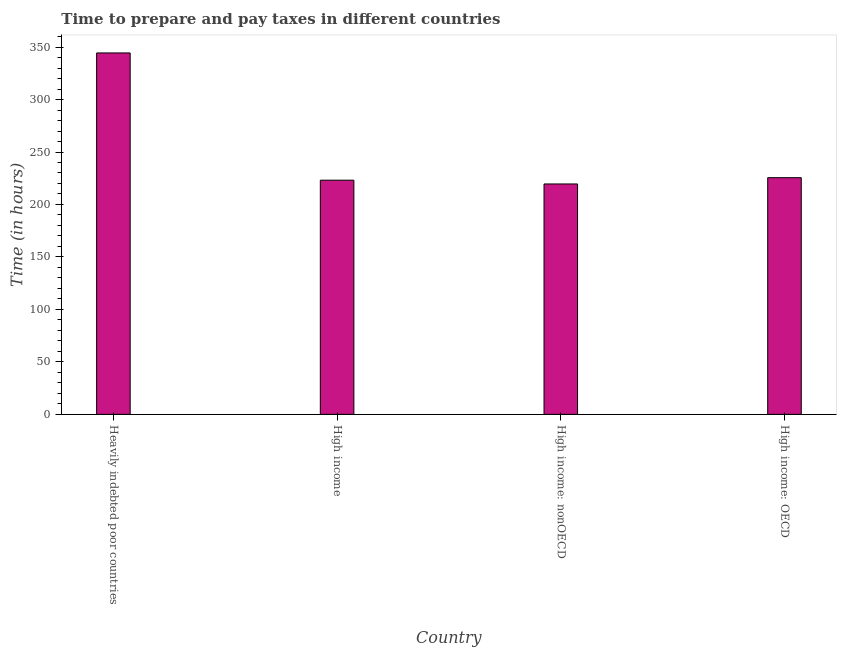Does the graph contain any zero values?
Offer a terse response. No. Does the graph contain grids?
Make the answer very short. No. What is the title of the graph?
Your response must be concise. Time to prepare and pay taxes in different countries. What is the label or title of the X-axis?
Your response must be concise. Country. What is the label or title of the Y-axis?
Provide a short and direct response. Time (in hours). What is the time to prepare and pay taxes in High income: nonOECD?
Provide a succinct answer. 219.55. Across all countries, what is the maximum time to prepare and pay taxes?
Make the answer very short. 344.39. Across all countries, what is the minimum time to prepare and pay taxes?
Provide a short and direct response. 219.55. In which country was the time to prepare and pay taxes maximum?
Your answer should be compact. Heavily indebted poor countries. In which country was the time to prepare and pay taxes minimum?
Your answer should be very brief. High income: nonOECD. What is the sum of the time to prepare and pay taxes?
Your answer should be very brief. 1012.62. What is the difference between the time to prepare and pay taxes in Heavily indebted poor countries and High income: nonOECD?
Keep it short and to the point. 124.84. What is the average time to prepare and pay taxes per country?
Your answer should be compact. 253.16. What is the median time to prepare and pay taxes?
Ensure brevity in your answer.  224.34. What is the ratio of the time to prepare and pay taxes in High income to that in High income: OECD?
Make the answer very short. 0.99. Is the time to prepare and pay taxes in High income less than that in High income: nonOECD?
Ensure brevity in your answer.  No. Is the difference between the time to prepare and pay taxes in High income and High income: OECD greater than the difference between any two countries?
Provide a succinct answer. No. What is the difference between the highest and the second highest time to prepare and pay taxes?
Your answer should be very brief. 118.86. What is the difference between the highest and the lowest time to prepare and pay taxes?
Your response must be concise. 124.84. In how many countries, is the time to prepare and pay taxes greater than the average time to prepare and pay taxes taken over all countries?
Provide a short and direct response. 1. What is the difference between two consecutive major ticks on the Y-axis?
Provide a succinct answer. 50. Are the values on the major ticks of Y-axis written in scientific E-notation?
Keep it short and to the point. No. What is the Time (in hours) in Heavily indebted poor countries?
Your answer should be very brief. 344.39. What is the Time (in hours) of High income?
Offer a terse response. 223.14. What is the Time (in hours) in High income: nonOECD?
Your answer should be compact. 219.55. What is the Time (in hours) of High income: OECD?
Your response must be concise. 225.53. What is the difference between the Time (in hours) in Heavily indebted poor countries and High income?
Provide a short and direct response. 121.25. What is the difference between the Time (in hours) in Heavily indebted poor countries and High income: nonOECD?
Offer a terse response. 124.84. What is the difference between the Time (in hours) in Heavily indebted poor countries and High income: OECD?
Your response must be concise. 118.86. What is the difference between the Time (in hours) in High income and High income: nonOECD?
Ensure brevity in your answer.  3.59. What is the difference between the Time (in hours) in High income and High income: OECD?
Your response must be concise. -2.39. What is the difference between the Time (in hours) in High income: nonOECD and High income: OECD?
Keep it short and to the point. -5.98. What is the ratio of the Time (in hours) in Heavily indebted poor countries to that in High income?
Provide a succinct answer. 1.54. What is the ratio of the Time (in hours) in Heavily indebted poor countries to that in High income: nonOECD?
Your answer should be very brief. 1.57. What is the ratio of the Time (in hours) in Heavily indebted poor countries to that in High income: OECD?
Your answer should be very brief. 1.53. What is the ratio of the Time (in hours) in High income to that in High income: OECD?
Your answer should be very brief. 0.99. 